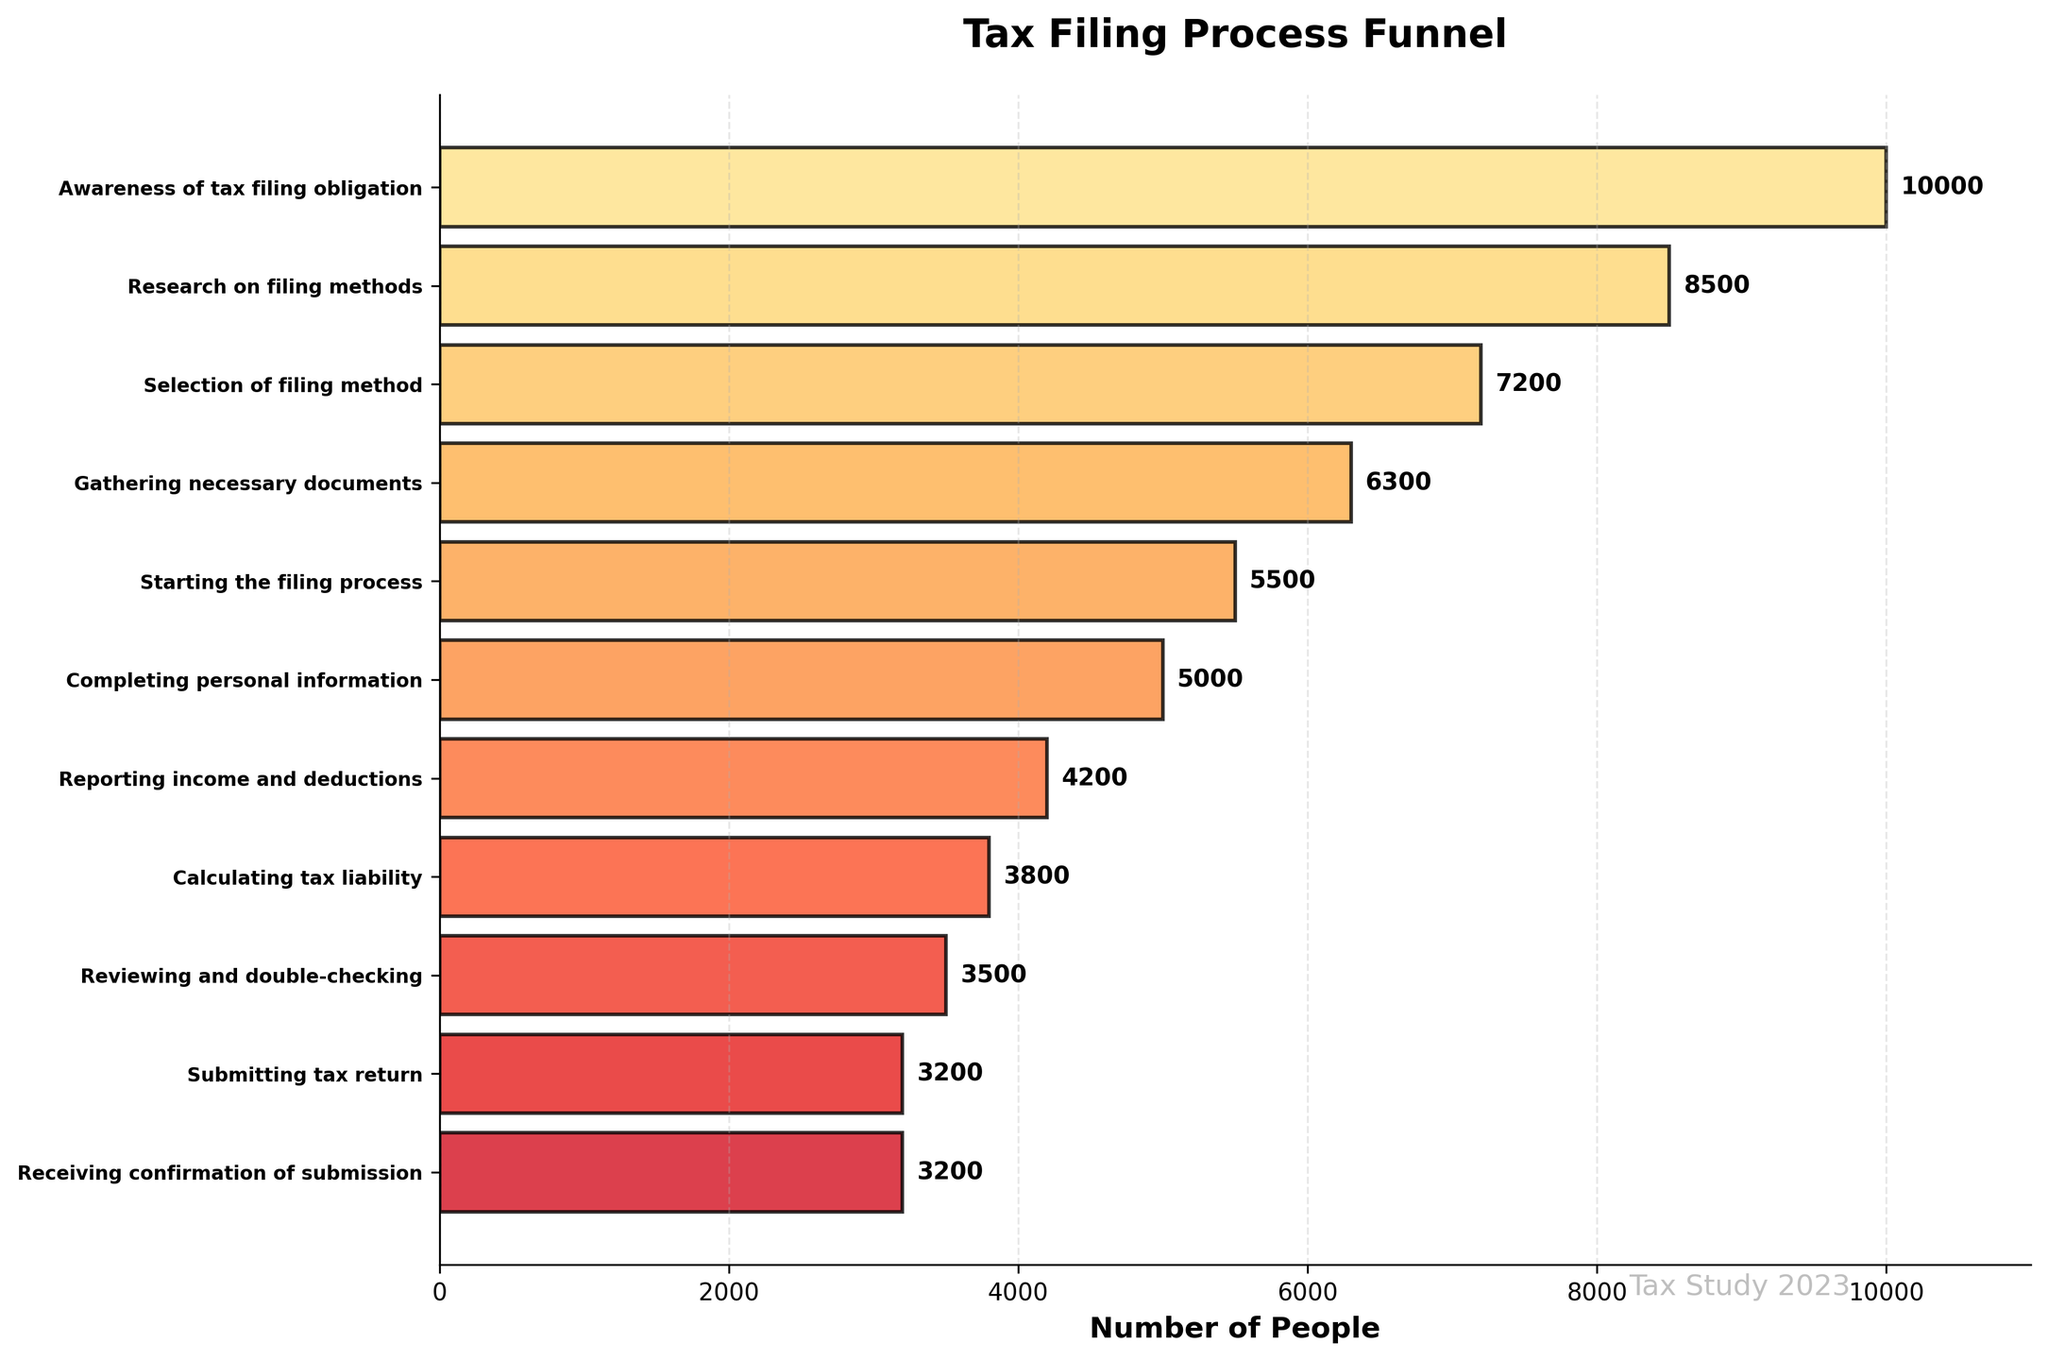How many people started the filing process? The figure shows the number of people at each stage. For the 'Starting the filing process' stage, the number of people is 5500
Answer: 5500 How many more people selected a filing method than gathered necessary documents? To find the difference, look at the two stages: 'Selection of filing method' (7200) and 'Gathering necessary documents' (6300). The difference is 7200 - 6300.
Answer: 900 Identify the stage with the largest drop in the number of people from the previous stage. Compare the decrease in numbers between consecutive stages. The biggest drop is between 'Gathering necessary documents' (6300) and 'Starting the filing process' (5500) which has a drop of 800.
Answer: 'Starting the filing process' How many stages are there in total? Count the number of distinct stages listed. There are 11 stages in the plot.
Answer: 11 What percentage of people who started the filing process completed the personal information stage? Divide the number of people in 'Completing personal information' (5000) by the number of people in 'Starting the filing process' (5500) and then multiply by 100 to get the percentage: (5000 / 5500) * 100.
Answer: ~90.91% Which stage retained the highest number of people relative to the number of people who started? To identify this, compare the numbers at each stage. The 'Awareness of tax filing obligation' stage has the highest number of 10000 people, which is the starting point.
Answer: 'Awareness of tax filing obligation' How many people did not complete the tax filing process after starting it? Subtract the number of people who received confirmation of submission (3200) from those who started the filing process (5500): 5500 - 3200.
Answer: 2300 Compare the number of people who calculated their tax liability to those who submitted their tax return. What trend do you observe? The number of people who calculated tax liability is 3800, and the number of people who submitted tax return is 3200, showing a reduction of 600. This indicates a drop-off before submission.
Answer: Reduction of 600 What is the overall completion rate of the tax filing process starting from awareness to confirmation of submission? Overall completion rate is calculated by dividing the number of people who received confirmation of submission (3200) by those who were aware of the tax filing obligation (10000), and then multiplying by 100: (3200 / 10000) * 100.
Answer: 32% At which stage did the number of participants first drop below 50% of the initial 10000 people? Calculate 50% of 10000, which is 5000. The first stage where the number drops below 5000 is 'Calculating tax liability' with 3800 people.
Answer: 'Calculating tax liability' 